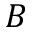Convert formula to latex. <formula><loc_0><loc_0><loc_500><loc_500>B</formula> 